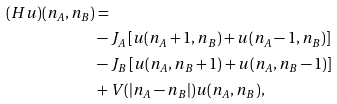Convert formula to latex. <formula><loc_0><loc_0><loc_500><loc_500>( H u ) ( n _ { A } , n _ { B } ) & = \\ & - J _ { A } \left [ u ( n _ { A } + 1 , n _ { B } ) + u ( n _ { A } - 1 , n _ { B } ) \right ] \\ & - J _ { B } \left [ u ( n _ { A } , n _ { B } + 1 ) + u ( n _ { A } , n _ { B } - 1 ) \right ] \\ & + V ( | n _ { A } - n _ { B } | ) u ( n _ { A } , n _ { B } ) ,</formula> 